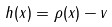<formula> <loc_0><loc_0><loc_500><loc_500>h ( x ) = \rho ( x ) - v</formula> 